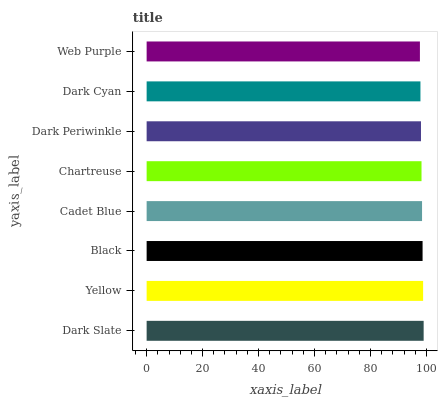Is Web Purple the minimum?
Answer yes or no. Yes. Is Dark Slate the maximum?
Answer yes or no. Yes. Is Yellow the minimum?
Answer yes or no. No. Is Yellow the maximum?
Answer yes or no. No. Is Dark Slate greater than Yellow?
Answer yes or no. Yes. Is Yellow less than Dark Slate?
Answer yes or no. Yes. Is Yellow greater than Dark Slate?
Answer yes or no. No. Is Dark Slate less than Yellow?
Answer yes or no. No. Is Cadet Blue the high median?
Answer yes or no. Yes. Is Chartreuse the low median?
Answer yes or no. Yes. Is Black the high median?
Answer yes or no. No. Is Dark Slate the low median?
Answer yes or no. No. 